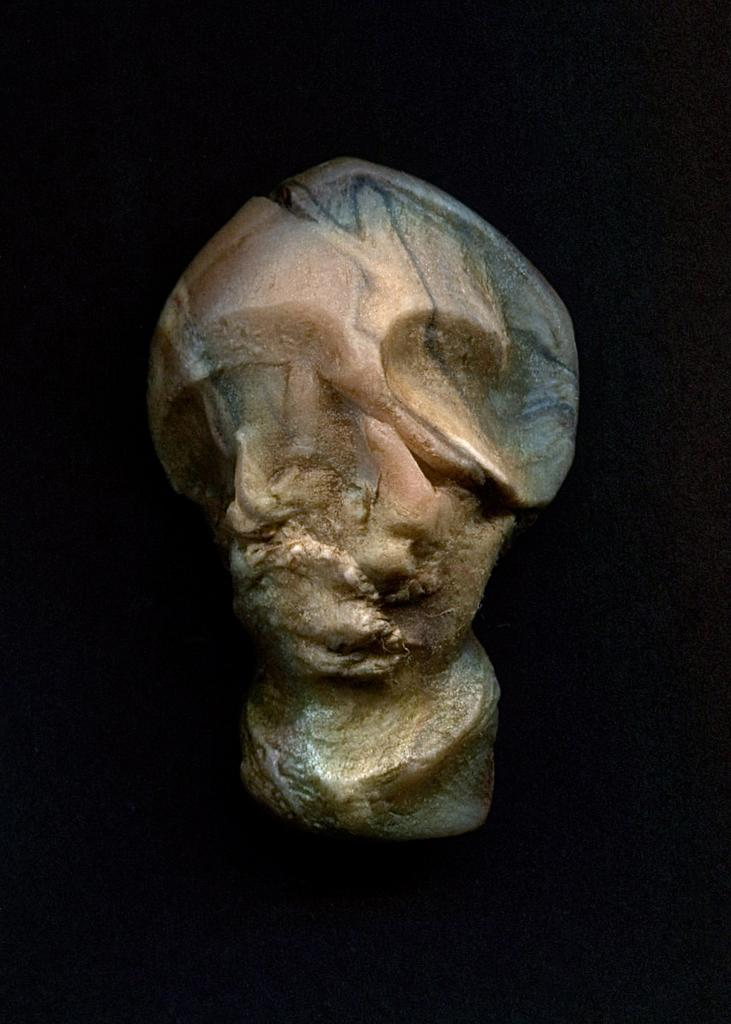What is the main subject of the image? There is a sculpture in the center of the image. What color is the background of the image? The background of the image is black. Can you see any clouds in the image? There are no clouds visible in the image, as the background is black and the focus is on the sculpture. Who created the sculpture in the image? The creator of the sculpture is not mentioned in the image or the provided facts, so it cannot be determined from the information given. 